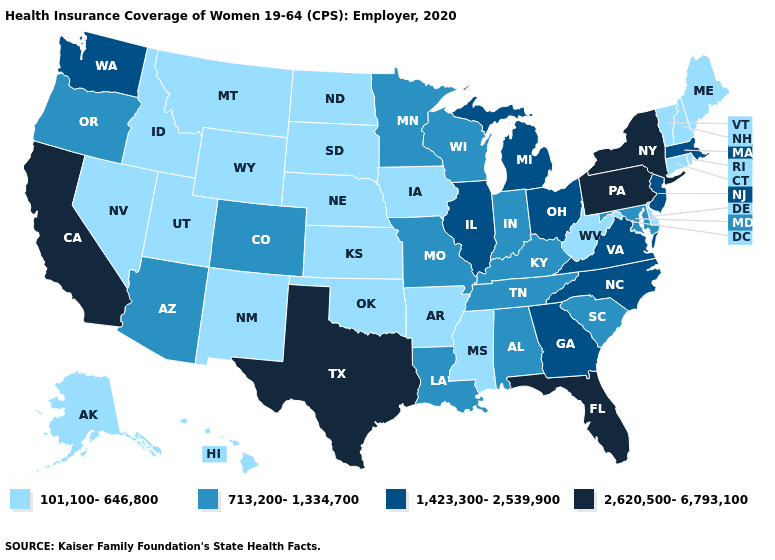What is the value of Nevada?
Write a very short answer. 101,100-646,800. Which states have the lowest value in the USA?
Short answer required. Alaska, Arkansas, Connecticut, Delaware, Hawaii, Idaho, Iowa, Kansas, Maine, Mississippi, Montana, Nebraska, Nevada, New Hampshire, New Mexico, North Dakota, Oklahoma, Rhode Island, South Dakota, Utah, Vermont, West Virginia, Wyoming. Name the states that have a value in the range 101,100-646,800?
Quick response, please. Alaska, Arkansas, Connecticut, Delaware, Hawaii, Idaho, Iowa, Kansas, Maine, Mississippi, Montana, Nebraska, Nevada, New Hampshire, New Mexico, North Dakota, Oklahoma, Rhode Island, South Dakota, Utah, Vermont, West Virginia, Wyoming. Which states have the highest value in the USA?
Answer briefly. California, Florida, New York, Pennsylvania, Texas. What is the lowest value in the USA?
Short answer required. 101,100-646,800. Name the states that have a value in the range 1,423,300-2,539,900?
Give a very brief answer. Georgia, Illinois, Massachusetts, Michigan, New Jersey, North Carolina, Ohio, Virginia, Washington. Does Louisiana have the lowest value in the South?
Answer briefly. No. Does the map have missing data?
Concise answer only. No. Name the states that have a value in the range 101,100-646,800?
Write a very short answer. Alaska, Arkansas, Connecticut, Delaware, Hawaii, Idaho, Iowa, Kansas, Maine, Mississippi, Montana, Nebraska, Nevada, New Hampshire, New Mexico, North Dakota, Oklahoma, Rhode Island, South Dakota, Utah, Vermont, West Virginia, Wyoming. What is the value of Minnesota?
Keep it brief. 713,200-1,334,700. Does Oregon have the same value as New York?
Be succinct. No. Is the legend a continuous bar?
Give a very brief answer. No. What is the value of Alabama?
Quick response, please. 713,200-1,334,700. Among the states that border Tennessee , does Virginia have the highest value?
Give a very brief answer. Yes. 